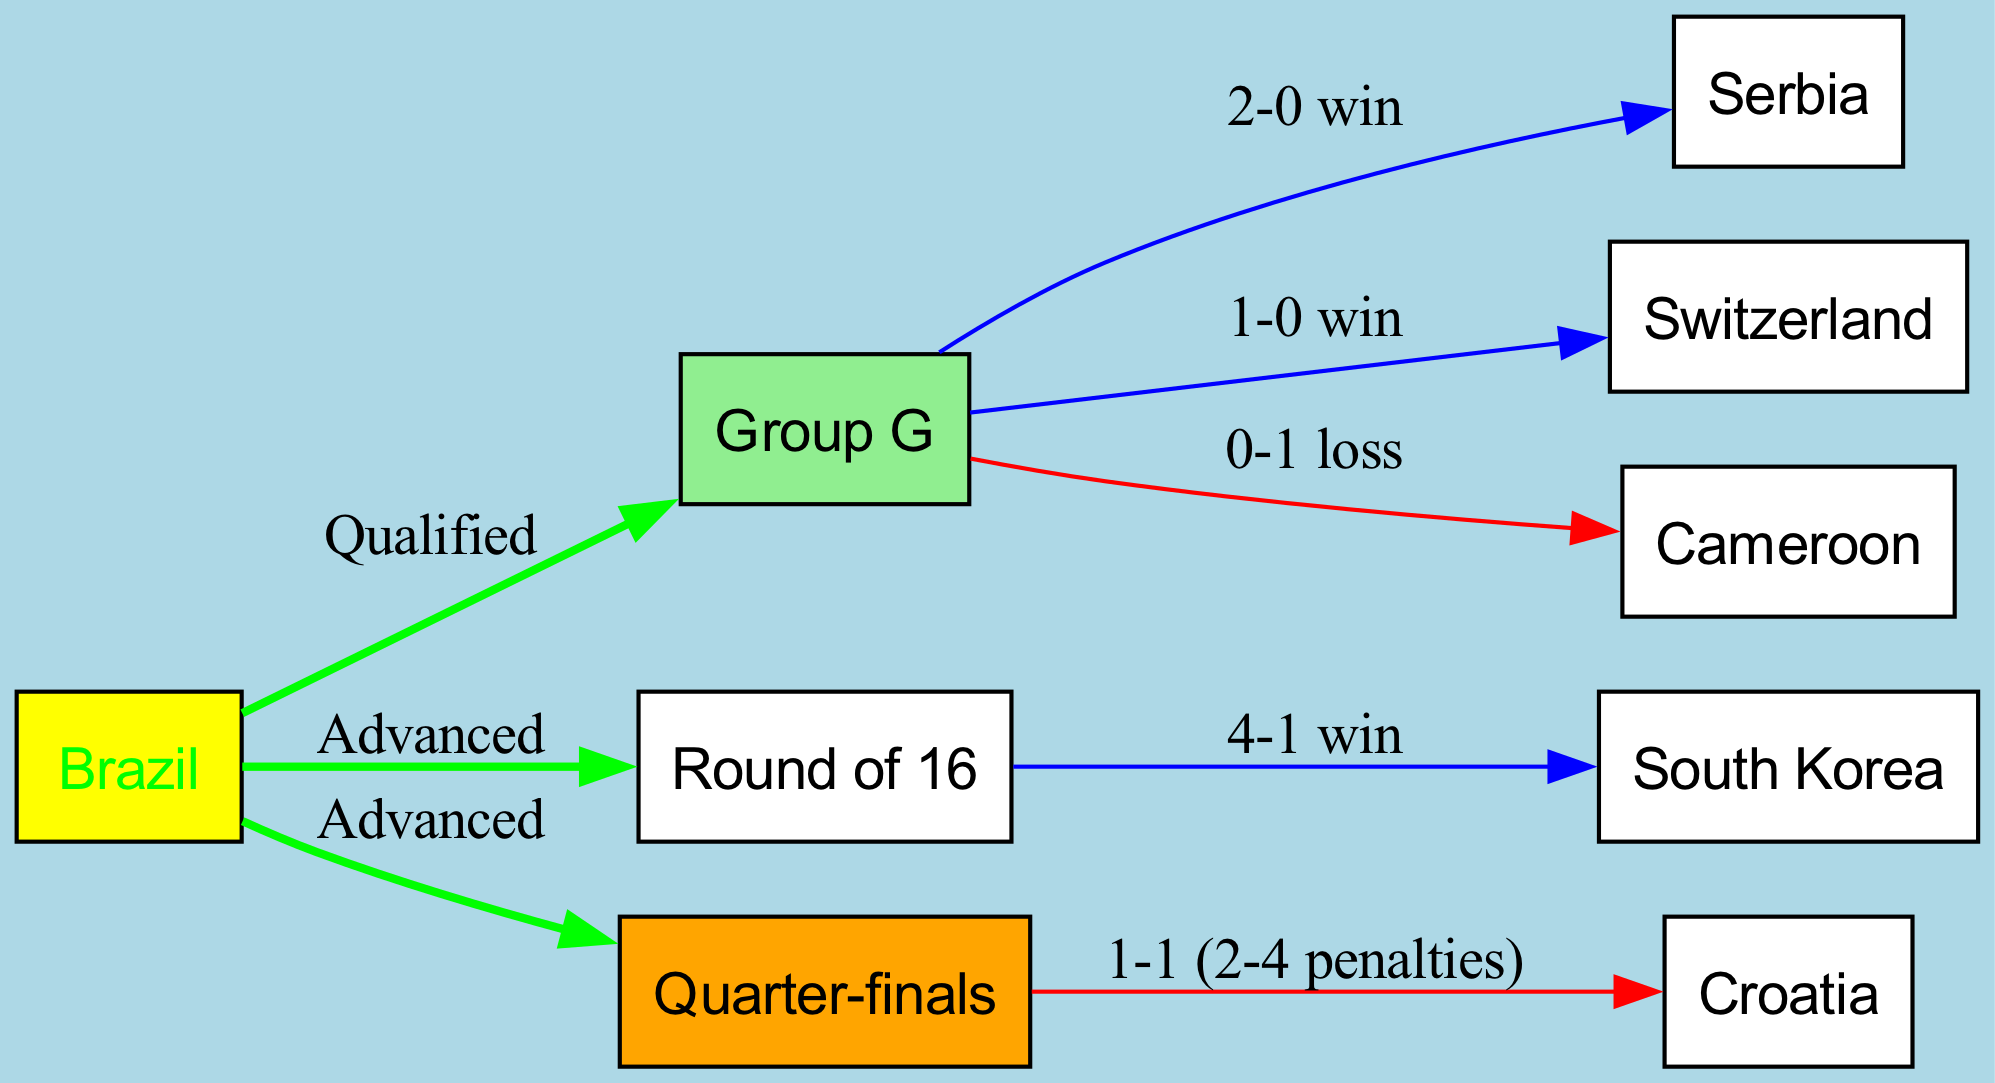What is the final outcome of Brazil in the Quarter-finals? The diagram indicates that Brazil faced Croatia in the Quarter-finals and the match result is noted as "1-1 (2-4 penalties)", which means Brazil lost after a penalty shootout.
Answer: Lost How many teams did Brazil face in the Group G stage? The diagram shows Brazil playing against three teams in Group G: Serbia, Switzerland, and Cameroon. Therefore, the total number of teams faced is three.
Answer: 3 What was Brazil's performance against South Korea in the Round of 16? According to the diagram, Brazil won against South Korea with a score of "4-1". This indicates a successful performance in that match.
Answer: 4-1 win What is the total number of matches Brazil played in the tournament based on the diagram? Brazil's journey consists of three Group Stage matches (against Serbia, Switzerland, Cameroon), one match in the Round of 16 (against South Korea), and one Quarter-finals match (against Croatia), totaling five matches.
Answer: 5 Did Brazil win any matches in Group G? The diagram indicates that Brazil won two matches in Group G against Serbia (2-0) and Switzerland (1-0), confirming that Brazil won matches.
Answer: Yes What edge represents Brazil's advancement to the Round of 16? In the diagram, there is an edge labeled "Advanced" between "Brazil" and "Round of 16", clearly indicating the connection of Brazil moving to the next round after the group stage.
Answer: Advanced Which team did Brazil not defeat in the Group G stage? The diagram clearly shows that Brazil lost to Cameroon with a score of "0-1", indicating that Cameroon is the team Brazil did not defeat in Group G.
Answer: Cameroon What was Brazil's performance in the Quarter-finals? The Quarter-finals match against Croatia resulted in a tie, with "1-1" being the score, followed by a loss in penalties ("2-4 penalties"). Therefore, the performance can be summarized as not advancing.
Answer: 1-1 (2-4 penalties) How did Brazil perform in the first match of the Group Stage? The first match listed in the diagram is against Serbia, where Brazil registered a "2-0 win", indicating a strong start in the group.
Answer: 2-0 win 